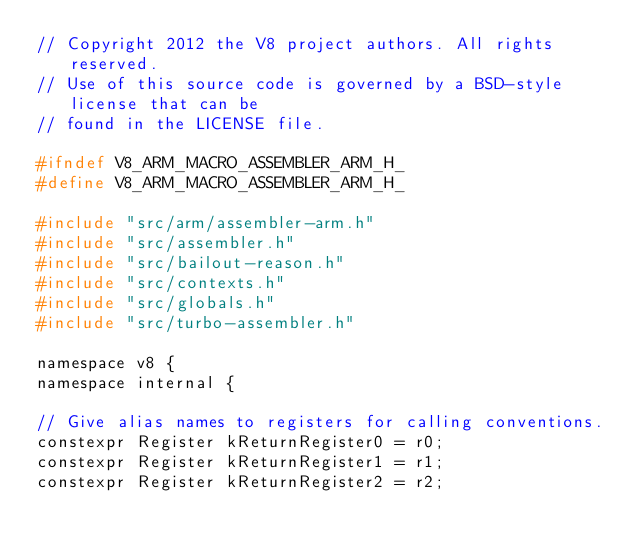Convert code to text. <code><loc_0><loc_0><loc_500><loc_500><_C_>// Copyright 2012 the V8 project authors. All rights reserved.
// Use of this source code is governed by a BSD-style license that can be
// found in the LICENSE file.

#ifndef V8_ARM_MACRO_ASSEMBLER_ARM_H_
#define V8_ARM_MACRO_ASSEMBLER_ARM_H_

#include "src/arm/assembler-arm.h"
#include "src/assembler.h"
#include "src/bailout-reason.h"
#include "src/contexts.h"
#include "src/globals.h"
#include "src/turbo-assembler.h"

namespace v8 {
namespace internal {

// Give alias names to registers for calling conventions.
constexpr Register kReturnRegister0 = r0;
constexpr Register kReturnRegister1 = r1;
constexpr Register kReturnRegister2 = r2;</code> 